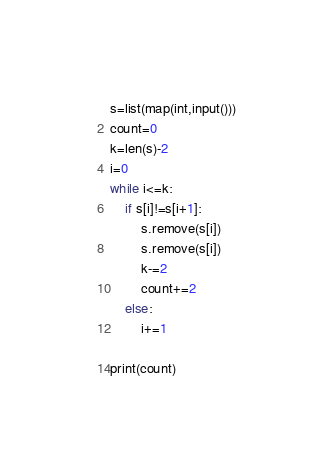<code> <loc_0><loc_0><loc_500><loc_500><_Python_>s=list(map(int,input()))
count=0
k=len(s)-2
i=0
while i<=k:
    if s[i]!=s[i+1]:
        s.remove(s[i])
        s.remove(s[i])
        k-=2
        count+=2
    else:
        i+=1
    
print(count)
</code> 